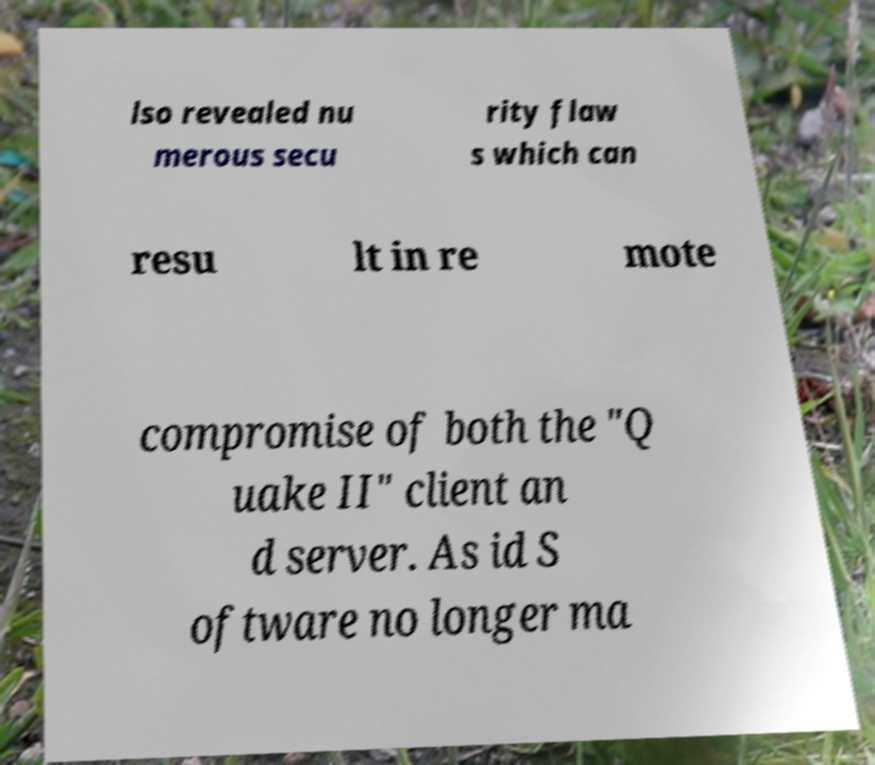Could you assist in decoding the text presented in this image and type it out clearly? lso revealed nu merous secu rity flaw s which can resu lt in re mote compromise of both the "Q uake II" client an d server. As id S oftware no longer ma 